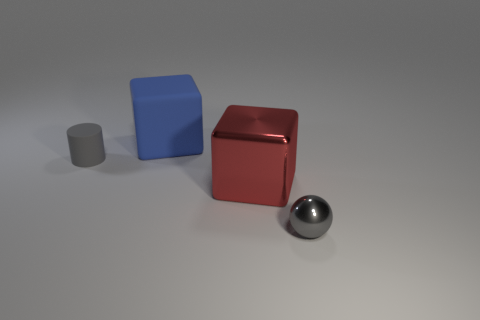Add 4 yellow objects. How many objects exist? 8 Subtract all balls. How many objects are left? 3 Add 2 tiny cylinders. How many tiny cylinders are left? 3 Add 1 tiny red rubber cylinders. How many tiny red rubber cylinders exist? 1 Subtract 0 green balls. How many objects are left? 4 Subtract all red metal cubes. Subtract all gray matte things. How many objects are left? 2 